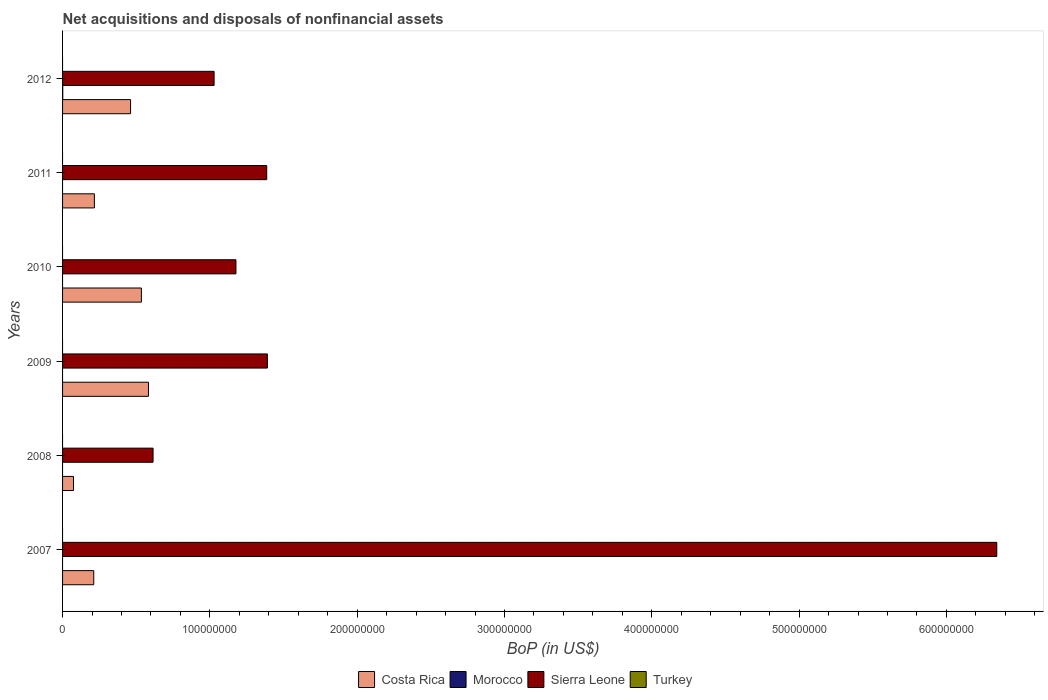How many different coloured bars are there?
Your answer should be very brief. 3. How many groups of bars are there?
Your response must be concise. 6. How many bars are there on the 4th tick from the top?
Provide a short and direct response. 2. How many bars are there on the 1st tick from the bottom?
Keep it short and to the point. 2. What is the label of the 3rd group of bars from the top?
Offer a very short reply. 2010. What is the Balance of Payments in Costa Rica in 2008?
Make the answer very short. 7.42e+06. Across all years, what is the maximum Balance of Payments in Costa Rica?
Provide a short and direct response. 5.83e+07. Across all years, what is the minimum Balance of Payments in Costa Rica?
Give a very brief answer. 7.42e+06. In which year was the Balance of Payments in Sierra Leone maximum?
Your answer should be very brief. 2007. What is the total Balance of Payments in Morocco in the graph?
Offer a terse response. 1.28e+05. What is the difference between the Balance of Payments in Costa Rica in 2010 and that in 2011?
Your answer should be compact. 3.19e+07. What is the average Balance of Payments in Morocco per year?
Make the answer very short. 2.14e+04. In the year 2007, what is the difference between the Balance of Payments in Sierra Leone and Balance of Payments in Costa Rica?
Your answer should be compact. 6.13e+08. In how many years, is the Balance of Payments in Morocco greater than 640000000 US$?
Keep it short and to the point. 0. What is the ratio of the Balance of Payments in Sierra Leone in 2008 to that in 2011?
Offer a very short reply. 0.44. Is the Balance of Payments in Costa Rica in 2007 less than that in 2010?
Keep it short and to the point. Yes. Is the difference between the Balance of Payments in Sierra Leone in 2010 and 2012 greater than the difference between the Balance of Payments in Costa Rica in 2010 and 2012?
Your response must be concise. Yes. What is the difference between the highest and the second highest Balance of Payments in Costa Rica?
Provide a short and direct response. 4.81e+06. What is the difference between the highest and the lowest Balance of Payments in Costa Rica?
Offer a very short reply. 5.09e+07. In how many years, is the Balance of Payments in Turkey greater than the average Balance of Payments in Turkey taken over all years?
Ensure brevity in your answer.  0. Is it the case that in every year, the sum of the Balance of Payments in Costa Rica and Balance of Payments in Turkey is greater than the Balance of Payments in Morocco?
Provide a succinct answer. Yes. How many bars are there?
Your response must be concise. 13. Does the graph contain any zero values?
Offer a very short reply. Yes. Does the graph contain grids?
Provide a short and direct response. No. Where does the legend appear in the graph?
Provide a succinct answer. Bottom center. How many legend labels are there?
Your answer should be very brief. 4. What is the title of the graph?
Make the answer very short. Net acquisitions and disposals of nonfinancial assets. What is the label or title of the X-axis?
Offer a very short reply. BoP (in US$). What is the label or title of the Y-axis?
Offer a terse response. Years. What is the BoP (in US$) in Costa Rica in 2007?
Make the answer very short. 2.12e+07. What is the BoP (in US$) in Morocco in 2007?
Provide a short and direct response. 0. What is the BoP (in US$) of Sierra Leone in 2007?
Keep it short and to the point. 6.34e+08. What is the BoP (in US$) of Costa Rica in 2008?
Your answer should be very brief. 7.42e+06. What is the BoP (in US$) in Morocco in 2008?
Your response must be concise. 0. What is the BoP (in US$) in Sierra Leone in 2008?
Your answer should be compact. 6.14e+07. What is the BoP (in US$) in Costa Rica in 2009?
Provide a short and direct response. 5.83e+07. What is the BoP (in US$) in Sierra Leone in 2009?
Your response must be concise. 1.39e+08. What is the BoP (in US$) of Costa Rica in 2010?
Keep it short and to the point. 5.35e+07. What is the BoP (in US$) of Sierra Leone in 2010?
Your answer should be compact. 1.18e+08. What is the BoP (in US$) of Costa Rica in 2011?
Offer a terse response. 2.16e+07. What is the BoP (in US$) of Morocco in 2011?
Make the answer very short. 0. What is the BoP (in US$) of Sierra Leone in 2011?
Provide a succinct answer. 1.39e+08. What is the BoP (in US$) in Turkey in 2011?
Offer a very short reply. 0. What is the BoP (in US$) of Costa Rica in 2012?
Provide a succinct answer. 4.62e+07. What is the BoP (in US$) of Morocco in 2012?
Keep it short and to the point. 1.28e+05. What is the BoP (in US$) of Sierra Leone in 2012?
Offer a very short reply. 1.03e+08. What is the BoP (in US$) in Turkey in 2012?
Give a very brief answer. 0. Across all years, what is the maximum BoP (in US$) of Costa Rica?
Keep it short and to the point. 5.83e+07. Across all years, what is the maximum BoP (in US$) of Morocco?
Give a very brief answer. 1.28e+05. Across all years, what is the maximum BoP (in US$) of Sierra Leone?
Your answer should be very brief. 6.34e+08. Across all years, what is the minimum BoP (in US$) of Costa Rica?
Your answer should be very brief. 7.42e+06. Across all years, what is the minimum BoP (in US$) in Morocco?
Give a very brief answer. 0. Across all years, what is the minimum BoP (in US$) of Sierra Leone?
Give a very brief answer. 6.14e+07. What is the total BoP (in US$) in Costa Rica in the graph?
Make the answer very short. 2.08e+08. What is the total BoP (in US$) of Morocco in the graph?
Offer a very short reply. 1.28e+05. What is the total BoP (in US$) in Sierra Leone in the graph?
Provide a succinct answer. 1.19e+09. What is the difference between the BoP (in US$) in Costa Rica in 2007 and that in 2008?
Offer a terse response. 1.37e+07. What is the difference between the BoP (in US$) in Sierra Leone in 2007 and that in 2008?
Give a very brief answer. 5.73e+08. What is the difference between the BoP (in US$) of Costa Rica in 2007 and that in 2009?
Make the answer very short. -3.72e+07. What is the difference between the BoP (in US$) of Sierra Leone in 2007 and that in 2009?
Offer a very short reply. 4.95e+08. What is the difference between the BoP (in US$) of Costa Rica in 2007 and that in 2010?
Your response must be concise. -3.23e+07. What is the difference between the BoP (in US$) of Sierra Leone in 2007 and that in 2010?
Provide a short and direct response. 5.16e+08. What is the difference between the BoP (in US$) in Costa Rica in 2007 and that in 2011?
Give a very brief answer. -4.38e+05. What is the difference between the BoP (in US$) of Sierra Leone in 2007 and that in 2011?
Provide a succinct answer. 4.96e+08. What is the difference between the BoP (in US$) in Costa Rica in 2007 and that in 2012?
Your answer should be very brief. -2.50e+07. What is the difference between the BoP (in US$) in Sierra Leone in 2007 and that in 2012?
Make the answer very short. 5.31e+08. What is the difference between the BoP (in US$) in Costa Rica in 2008 and that in 2009?
Your answer should be compact. -5.09e+07. What is the difference between the BoP (in US$) in Sierra Leone in 2008 and that in 2009?
Offer a terse response. -7.76e+07. What is the difference between the BoP (in US$) in Costa Rica in 2008 and that in 2010?
Give a very brief answer. -4.61e+07. What is the difference between the BoP (in US$) of Sierra Leone in 2008 and that in 2010?
Your answer should be compact. -5.63e+07. What is the difference between the BoP (in US$) of Costa Rica in 2008 and that in 2011?
Offer a terse response. -1.42e+07. What is the difference between the BoP (in US$) in Sierra Leone in 2008 and that in 2011?
Offer a very short reply. -7.72e+07. What is the difference between the BoP (in US$) of Costa Rica in 2008 and that in 2012?
Provide a short and direct response. -3.88e+07. What is the difference between the BoP (in US$) of Sierra Leone in 2008 and that in 2012?
Make the answer very short. -4.14e+07. What is the difference between the BoP (in US$) in Costa Rica in 2009 and that in 2010?
Your answer should be very brief. 4.81e+06. What is the difference between the BoP (in US$) in Sierra Leone in 2009 and that in 2010?
Give a very brief answer. 2.13e+07. What is the difference between the BoP (in US$) in Costa Rica in 2009 and that in 2011?
Your answer should be compact. 3.67e+07. What is the difference between the BoP (in US$) of Sierra Leone in 2009 and that in 2011?
Keep it short and to the point. 4.53e+05. What is the difference between the BoP (in US$) of Costa Rica in 2009 and that in 2012?
Ensure brevity in your answer.  1.21e+07. What is the difference between the BoP (in US$) of Sierra Leone in 2009 and that in 2012?
Make the answer very short. 3.62e+07. What is the difference between the BoP (in US$) of Costa Rica in 2010 and that in 2011?
Provide a succinct answer. 3.19e+07. What is the difference between the BoP (in US$) of Sierra Leone in 2010 and that in 2011?
Offer a very short reply. -2.09e+07. What is the difference between the BoP (in US$) in Costa Rica in 2010 and that in 2012?
Offer a terse response. 7.33e+06. What is the difference between the BoP (in US$) of Sierra Leone in 2010 and that in 2012?
Provide a succinct answer. 1.48e+07. What is the difference between the BoP (in US$) of Costa Rica in 2011 and that in 2012?
Offer a terse response. -2.46e+07. What is the difference between the BoP (in US$) in Sierra Leone in 2011 and that in 2012?
Make the answer very short. 3.57e+07. What is the difference between the BoP (in US$) in Costa Rica in 2007 and the BoP (in US$) in Sierra Leone in 2008?
Provide a short and direct response. -4.03e+07. What is the difference between the BoP (in US$) in Costa Rica in 2007 and the BoP (in US$) in Sierra Leone in 2009?
Your response must be concise. -1.18e+08. What is the difference between the BoP (in US$) of Costa Rica in 2007 and the BoP (in US$) of Sierra Leone in 2010?
Your answer should be very brief. -9.65e+07. What is the difference between the BoP (in US$) of Costa Rica in 2007 and the BoP (in US$) of Sierra Leone in 2011?
Provide a succinct answer. -1.17e+08. What is the difference between the BoP (in US$) in Costa Rica in 2007 and the BoP (in US$) in Morocco in 2012?
Offer a very short reply. 2.10e+07. What is the difference between the BoP (in US$) in Costa Rica in 2007 and the BoP (in US$) in Sierra Leone in 2012?
Offer a very short reply. -8.17e+07. What is the difference between the BoP (in US$) of Costa Rica in 2008 and the BoP (in US$) of Sierra Leone in 2009?
Keep it short and to the point. -1.32e+08. What is the difference between the BoP (in US$) of Costa Rica in 2008 and the BoP (in US$) of Sierra Leone in 2010?
Your response must be concise. -1.10e+08. What is the difference between the BoP (in US$) in Costa Rica in 2008 and the BoP (in US$) in Sierra Leone in 2011?
Your answer should be very brief. -1.31e+08. What is the difference between the BoP (in US$) in Costa Rica in 2008 and the BoP (in US$) in Morocco in 2012?
Give a very brief answer. 7.29e+06. What is the difference between the BoP (in US$) of Costa Rica in 2008 and the BoP (in US$) of Sierra Leone in 2012?
Provide a succinct answer. -9.54e+07. What is the difference between the BoP (in US$) in Costa Rica in 2009 and the BoP (in US$) in Sierra Leone in 2010?
Provide a succinct answer. -5.94e+07. What is the difference between the BoP (in US$) in Costa Rica in 2009 and the BoP (in US$) in Sierra Leone in 2011?
Make the answer very short. -8.03e+07. What is the difference between the BoP (in US$) of Costa Rica in 2009 and the BoP (in US$) of Morocco in 2012?
Your answer should be compact. 5.82e+07. What is the difference between the BoP (in US$) of Costa Rica in 2009 and the BoP (in US$) of Sierra Leone in 2012?
Make the answer very short. -4.45e+07. What is the difference between the BoP (in US$) in Costa Rica in 2010 and the BoP (in US$) in Sierra Leone in 2011?
Ensure brevity in your answer.  -8.51e+07. What is the difference between the BoP (in US$) of Costa Rica in 2010 and the BoP (in US$) of Morocco in 2012?
Offer a very short reply. 5.34e+07. What is the difference between the BoP (in US$) of Costa Rica in 2010 and the BoP (in US$) of Sierra Leone in 2012?
Provide a short and direct response. -4.94e+07. What is the difference between the BoP (in US$) of Costa Rica in 2011 and the BoP (in US$) of Morocco in 2012?
Your answer should be compact. 2.15e+07. What is the difference between the BoP (in US$) of Costa Rica in 2011 and the BoP (in US$) of Sierra Leone in 2012?
Provide a short and direct response. -8.13e+07. What is the average BoP (in US$) in Costa Rica per year?
Your answer should be very brief. 3.47e+07. What is the average BoP (in US$) of Morocco per year?
Your response must be concise. 2.14e+04. What is the average BoP (in US$) of Sierra Leone per year?
Make the answer very short. 1.99e+08. In the year 2007, what is the difference between the BoP (in US$) of Costa Rica and BoP (in US$) of Sierra Leone?
Your answer should be compact. -6.13e+08. In the year 2008, what is the difference between the BoP (in US$) of Costa Rica and BoP (in US$) of Sierra Leone?
Offer a very short reply. -5.40e+07. In the year 2009, what is the difference between the BoP (in US$) of Costa Rica and BoP (in US$) of Sierra Leone?
Offer a terse response. -8.07e+07. In the year 2010, what is the difference between the BoP (in US$) of Costa Rica and BoP (in US$) of Sierra Leone?
Make the answer very short. -6.42e+07. In the year 2011, what is the difference between the BoP (in US$) in Costa Rica and BoP (in US$) in Sierra Leone?
Your answer should be very brief. -1.17e+08. In the year 2012, what is the difference between the BoP (in US$) in Costa Rica and BoP (in US$) in Morocco?
Your answer should be compact. 4.60e+07. In the year 2012, what is the difference between the BoP (in US$) in Costa Rica and BoP (in US$) in Sierra Leone?
Offer a terse response. -5.67e+07. In the year 2012, what is the difference between the BoP (in US$) of Morocco and BoP (in US$) of Sierra Leone?
Ensure brevity in your answer.  -1.03e+08. What is the ratio of the BoP (in US$) of Costa Rica in 2007 to that in 2008?
Your answer should be compact. 2.85. What is the ratio of the BoP (in US$) in Sierra Leone in 2007 to that in 2008?
Offer a terse response. 10.32. What is the ratio of the BoP (in US$) in Costa Rica in 2007 to that in 2009?
Give a very brief answer. 0.36. What is the ratio of the BoP (in US$) in Sierra Leone in 2007 to that in 2009?
Offer a terse response. 4.56. What is the ratio of the BoP (in US$) in Costa Rica in 2007 to that in 2010?
Give a very brief answer. 0.4. What is the ratio of the BoP (in US$) of Sierra Leone in 2007 to that in 2010?
Provide a short and direct response. 5.39. What is the ratio of the BoP (in US$) of Costa Rica in 2007 to that in 2011?
Your response must be concise. 0.98. What is the ratio of the BoP (in US$) of Sierra Leone in 2007 to that in 2011?
Your answer should be compact. 4.58. What is the ratio of the BoP (in US$) in Costa Rica in 2007 to that in 2012?
Provide a short and direct response. 0.46. What is the ratio of the BoP (in US$) in Sierra Leone in 2007 to that in 2012?
Your answer should be very brief. 6.17. What is the ratio of the BoP (in US$) of Costa Rica in 2008 to that in 2009?
Give a very brief answer. 0.13. What is the ratio of the BoP (in US$) in Sierra Leone in 2008 to that in 2009?
Your answer should be compact. 0.44. What is the ratio of the BoP (in US$) of Costa Rica in 2008 to that in 2010?
Provide a short and direct response. 0.14. What is the ratio of the BoP (in US$) in Sierra Leone in 2008 to that in 2010?
Offer a very short reply. 0.52. What is the ratio of the BoP (in US$) in Costa Rica in 2008 to that in 2011?
Offer a very short reply. 0.34. What is the ratio of the BoP (in US$) in Sierra Leone in 2008 to that in 2011?
Give a very brief answer. 0.44. What is the ratio of the BoP (in US$) in Costa Rica in 2008 to that in 2012?
Keep it short and to the point. 0.16. What is the ratio of the BoP (in US$) of Sierra Leone in 2008 to that in 2012?
Keep it short and to the point. 0.6. What is the ratio of the BoP (in US$) in Costa Rica in 2009 to that in 2010?
Your response must be concise. 1.09. What is the ratio of the BoP (in US$) of Sierra Leone in 2009 to that in 2010?
Ensure brevity in your answer.  1.18. What is the ratio of the BoP (in US$) of Costa Rica in 2009 to that in 2011?
Offer a very short reply. 2.7. What is the ratio of the BoP (in US$) in Costa Rica in 2009 to that in 2012?
Give a very brief answer. 1.26. What is the ratio of the BoP (in US$) of Sierra Leone in 2009 to that in 2012?
Your response must be concise. 1.35. What is the ratio of the BoP (in US$) in Costa Rica in 2010 to that in 2011?
Provide a short and direct response. 2.48. What is the ratio of the BoP (in US$) in Sierra Leone in 2010 to that in 2011?
Provide a short and direct response. 0.85. What is the ratio of the BoP (in US$) of Costa Rica in 2010 to that in 2012?
Your answer should be compact. 1.16. What is the ratio of the BoP (in US$) of Sierra Leone in 2010 to that in 2012?
Your answer should be very brief. 1.14. What is the ratio of the BoP (in US$) of Costa Rica in 2011 to that in 2012?
Provide a succinct answer. 0.47. What is the ratio of the BoP (in US$) in Sierra Leone in 2011 to that in 2012?
Offer a terse response. 1.35. What is the difference between the highest and the second highest BoP (in US$) of Costa Rica?
Provide a succinct answer. 4.81e+06. What is the difference between the highest and the second highest BoP (in US$) in Sierra Leone?
Offer a terse response. 4.95e+08. What is the difference between the highest and the lowest BoP (in US$) in Costa Rica?
Offer a terse response. 5.09e+07. What is the difference between the highest and the lowest BoP (in US$) of Morocco?
Ensure brevity in your answer.  1.28e+05. What is the difference between the highest and the lowest BoP (in US$) in Sierra Leone?
Provide a succinct answer. 5.73e+08. 